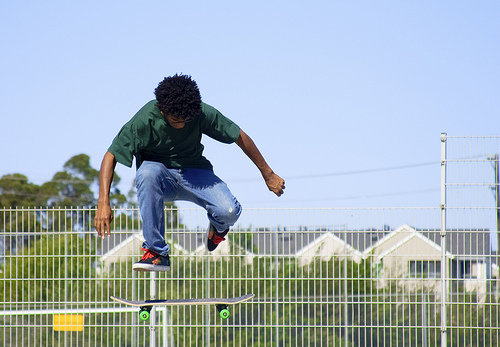<image>
Is there a child on the fence? No. The child is not positioned on the fence. They may be near each other, but the child is not supported by or resting on top of the fence. 